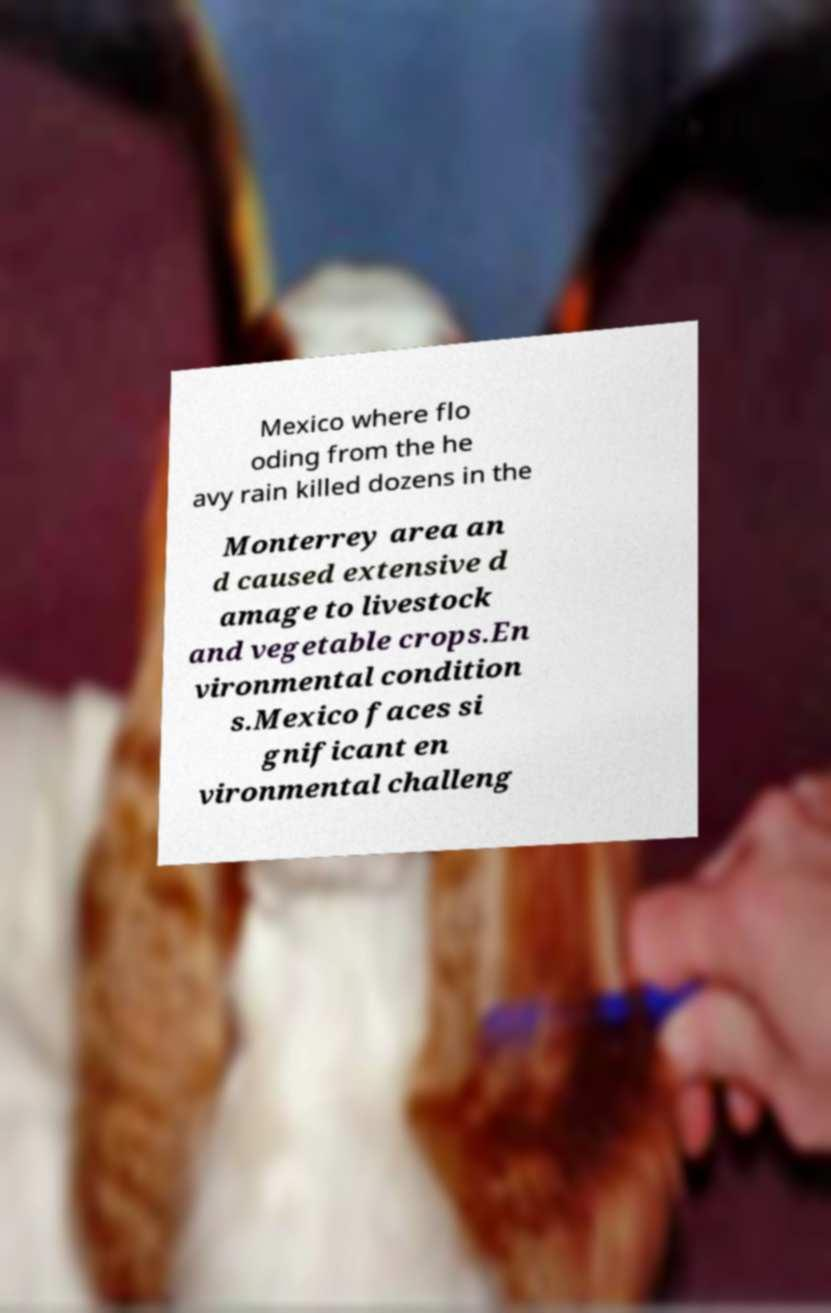Please read and relay the text visible in this image. What does it say? Mexico where flo oding from the he avy rain killed dozens in the Monterrey area an d caused extensive d amage to livestock and vegetable crops.En vironmental condition s.Mexico faces si gnificant en vironmental challeng 